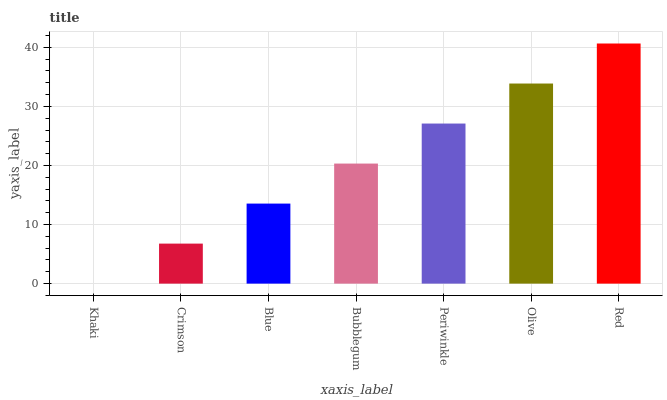Is Khaki the minimum?
Answer yes or no. Yes. Is Red the maximum?
Answer yes or no. Yes. Is Crimson the minimum?
Answer yes or no. No. Is Crimson the maximum?
Answer yes or no. No. Is Crimson greater than Khaki?
Answer yes or no. Yes. Is Khaki less than Crimson?
Answer yes or no. Yes. Is Khaki greater than Crimson?
Answer yes or no. No. Is Crimson less than Khaki?
Answer yes or no. No. Is Bubblegum the high median?
Answer yes or no. Yes. Is Bubblegum the low median?
Answer yes or no. Yes. Is Blue the high median?
Answer yes or no. No. Is Red the low median?
Answer yes or no. No. 